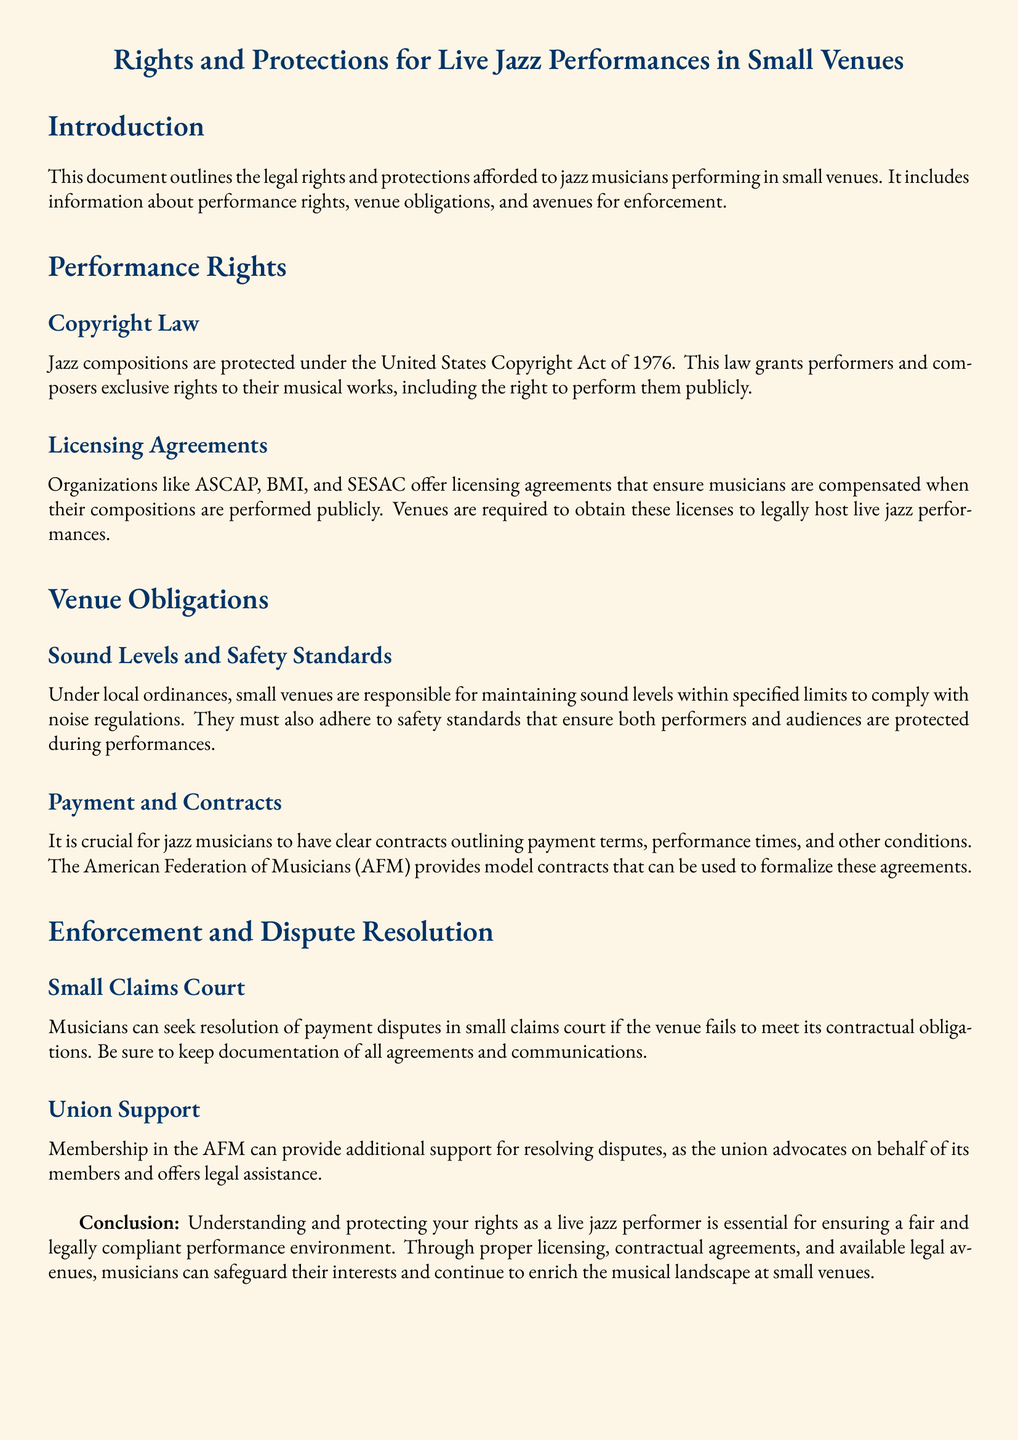What is the year of the Copyright Act mentioned? The document states that jazz compositions are protected under the United States Copyright Act of 1976.
Answer: 1976 What does ASCAP stand for? The document mentions ASCAP as one of the organizations that offer licensing agreements to musicians.
Answer: ASCAP What must venues obtain to host live jazz performances? The document specifies that venues are required to obtain licensing agreements to legally host performances.
Answer: Licensing agreements What organization provides model contracts for payment terms? The document indicates that the American Federation of Musicians provides model contracts to formalize agreements.
Answer: American Federation of Musicians What court can musicians use to resolve payment disputes? The document states that musicians can seek resolution in small claims court for payment disputes with venues.
Answer: Small claims court How can union membership benefit jazz musicians? The document explains that membership in the AFM can provide additional support for resolving disputes and legal assistance.
Answer: Additional support What are venues obligated to maintain according to local ordinances? The document notes that small venues are responsible for maintaining sound levels within specified limits.
Answer: Sound levels What is essential for a fair performance environment? The document concludes that understanding and protecting rights is essential for a fair performance environment.
Answer: Understanding rights 